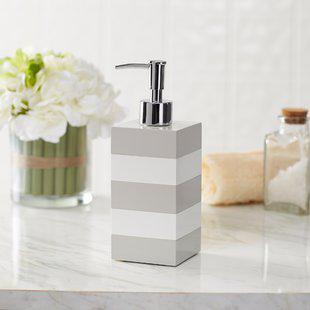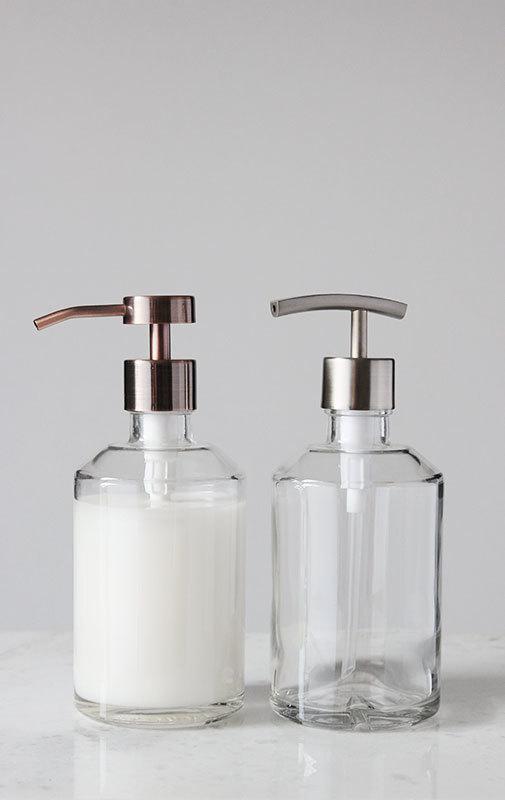The first image is the image on the left, the second image is the image on the right. Analyze the images presented: Is the assertion "The left and right image contains the same number of soap dispenser that sit on the sink." valid? Answer yes or no. No. The first image is the image on the left, the second image is the image on the right. For the images displayed, is the sentence "There is a clear dispenser with white lotion in it." factually correct? Answer yes or no. Yes. 